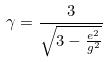Convert formula to latex. <formula><loc_0><loc_0><loc_500><loc_500>\gamma = \frac { 3 } { \sqrt { 3 - \frac { e ^ { 2 } } { g ^ { 2 } } } }</formula> 